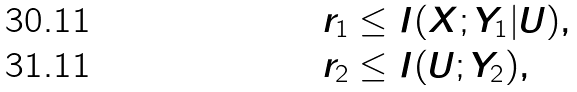Convert formula to latex. <formula><loc_0><loc_0><loc_500><loc_500>r _ { 1 } & \leq I ( X ; Y _ { 1 } | U ) , \\ r _ { 2 } & \leq I ( U ; Y _ { 2 } ) ,</formula> 